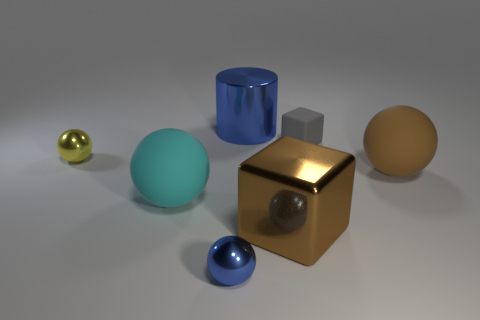Subtract all yellow balls. How many balls are left? 3 Subtract 2 balls. How many balls are left? 2 Add 1 large matte balls. How many objects exist? 8 Subtract all purple spheres. Subtract all blue blocks. How many spheres are left? 4 Subtract 0 green cylinders. How many objects are left? 7 Subtract all cubes. How many objects are left? 5 Subtract all large things. Subtract all yellow metal objects. How many objects are left? 2 Add 1 big brown shiny objects. How many big brown shiny objects are left? 2 Add 2 big spheres. How many big spheres exist? 4 